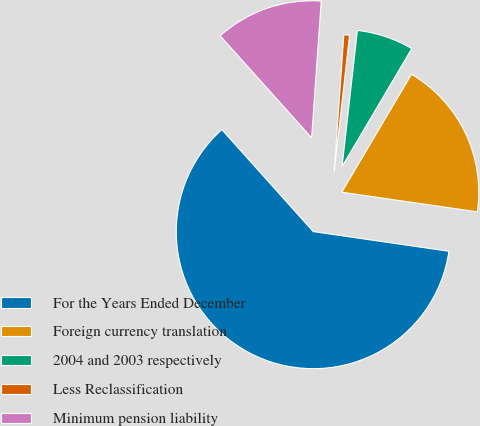Convert chart to OTSL. <chart><loc_0><loc_0><loc_500><loc_500><pie_chart><fcel>For the Years Ended December<fcel>Foreign currency translation<fcel>2004 and 2003 respectively<fcel>Less Reclassification<fcel>Minimum pension liability<nl><fcel>61.07%<fcel>18.79%<fcel>6.71%<fcel>0.67%<fcel>12.75%<nl></chart> 